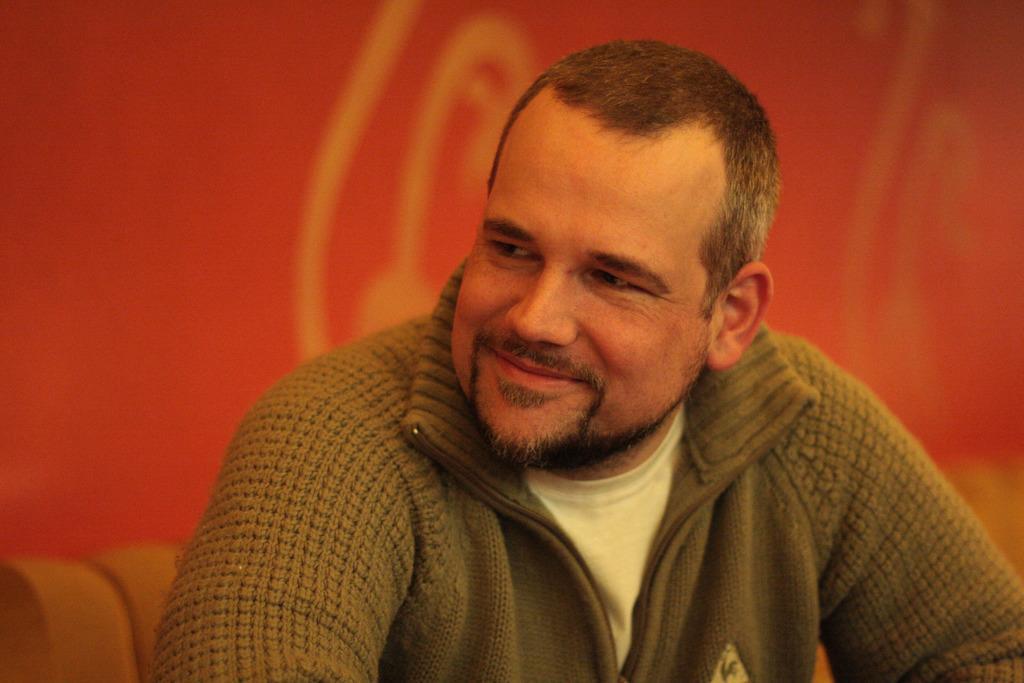In one or two sentences, can you explain what this image depicts? In the center of this picture we can see a man smiling and seems to be sitting. In the background we can see a red color object. 